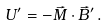<formula> <loc_0><loc_0><loc_500><loc_500>U ^ { \prime } = - \vec { M } \cdot \vec { B } ^ { \prime } \, .</formula> 